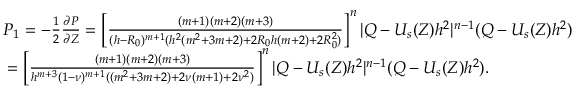Convert formula to latex. <formula><loc_0><loc_0><loc_500><loc_500>\begin{array} { r } { P _ { 1 } = - \frac { 1 } { 2 } \frac { \partial P } { \partial Z } = \left [ \frac { ( m + 1 ) ( m + 2 ) ( m + 3 ) } { ( h - R _ { 0 } ) ^ { m + 1 } ( h ^ { 2 } ( m ^ { 2 } + 3 m + 2 ) + 2 R _ { 0 } h ( m + 2 ) + 2 R _ { 0 } ^ { 2 } ) } \right ] ^ { n } | Q - U _ { s } ( Z ) h ^ { 2 } | ^ { n - 1 } ( Q - U _ { s } ( Z ) h ^ { 2 } ) } \\ { = \left [ \frac { ( m + 1 ) ( m + 2 ) ( m + 3 ) } { h ^ { m + 3 } ( 1 - \nu ) ^ { m + 1 } ( ( m ^ { 2 } + 3 m + 2 ) + 2 \nu ( m + 1 ) + 2 \nu ^ { 2 } ) } \right ] ^ { n } | Q - U _ { s } ( Z ) h ^ { 2 } | ^ { n - 1 } ( Q - U _ { s } ( Z ) h ^ { 2 } ) . } \end{array}</formula> 